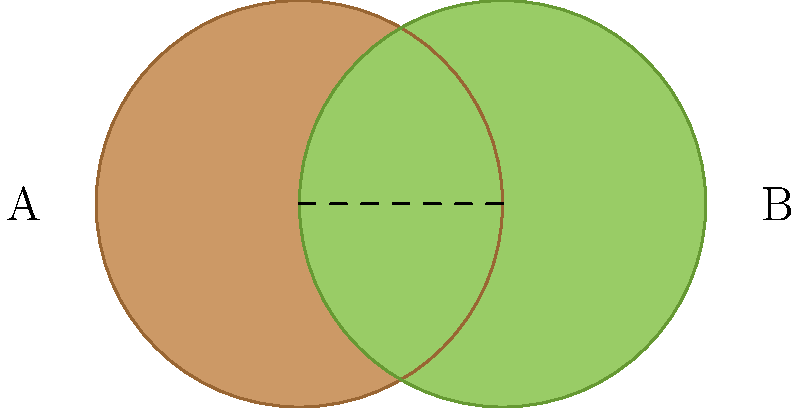Two circular tea cups, viewed from above, partially overlap as shown in the diagram. If the radius of each cup is 1 unit and the distance between their centers is also 1 unit, what is the area of the overlapping region? To find the area of the overlapping region, we can follow these steps:

1) First, we need to recognize that this is a case of two circles intersecting. The overlapping region is called a lens.

2) The formula for the area of a lens is:

   $A = 2r^2 \arccos(\frac{d}{2r}) - d\sqrt{r^2 - (\frac{d}{2})^2}$

   Where $r$ is the radius of each circle and $d$ is the distance between their centers.

3) We're given that $r = 1$ and $d = 1$. Let's substitute these values:

   $A = 2(1)^2 \arccos(\frac{1}{2(1)}) - 1\sqrt{1^2 - (\frac{1}{2})^2}$

4) Simplify:
   $A = 2 \arccos(\frac{1}{2}) - \sqrt{1 - \frac{1}{4}}$
   $A = 2 \arccos(\frac{1}{2}) - \sqrt{\frac{3}{4}}$

5) Calculate:
   $\arccos(\frac{1}{2}) \approx 1.0472$ (in radians)
   $\sqrt{\frac{3}{4}} \approx 0.8660$

6) Therefore:
   $A \approx 2(1.0472) - 0.8660$
   $A \approx 2.0944 - 0.8660$
   $A \approx 1.2284$

The area of the overlapping region is approximately 1.2284 square units.
Answer: $1.2284$ square units 